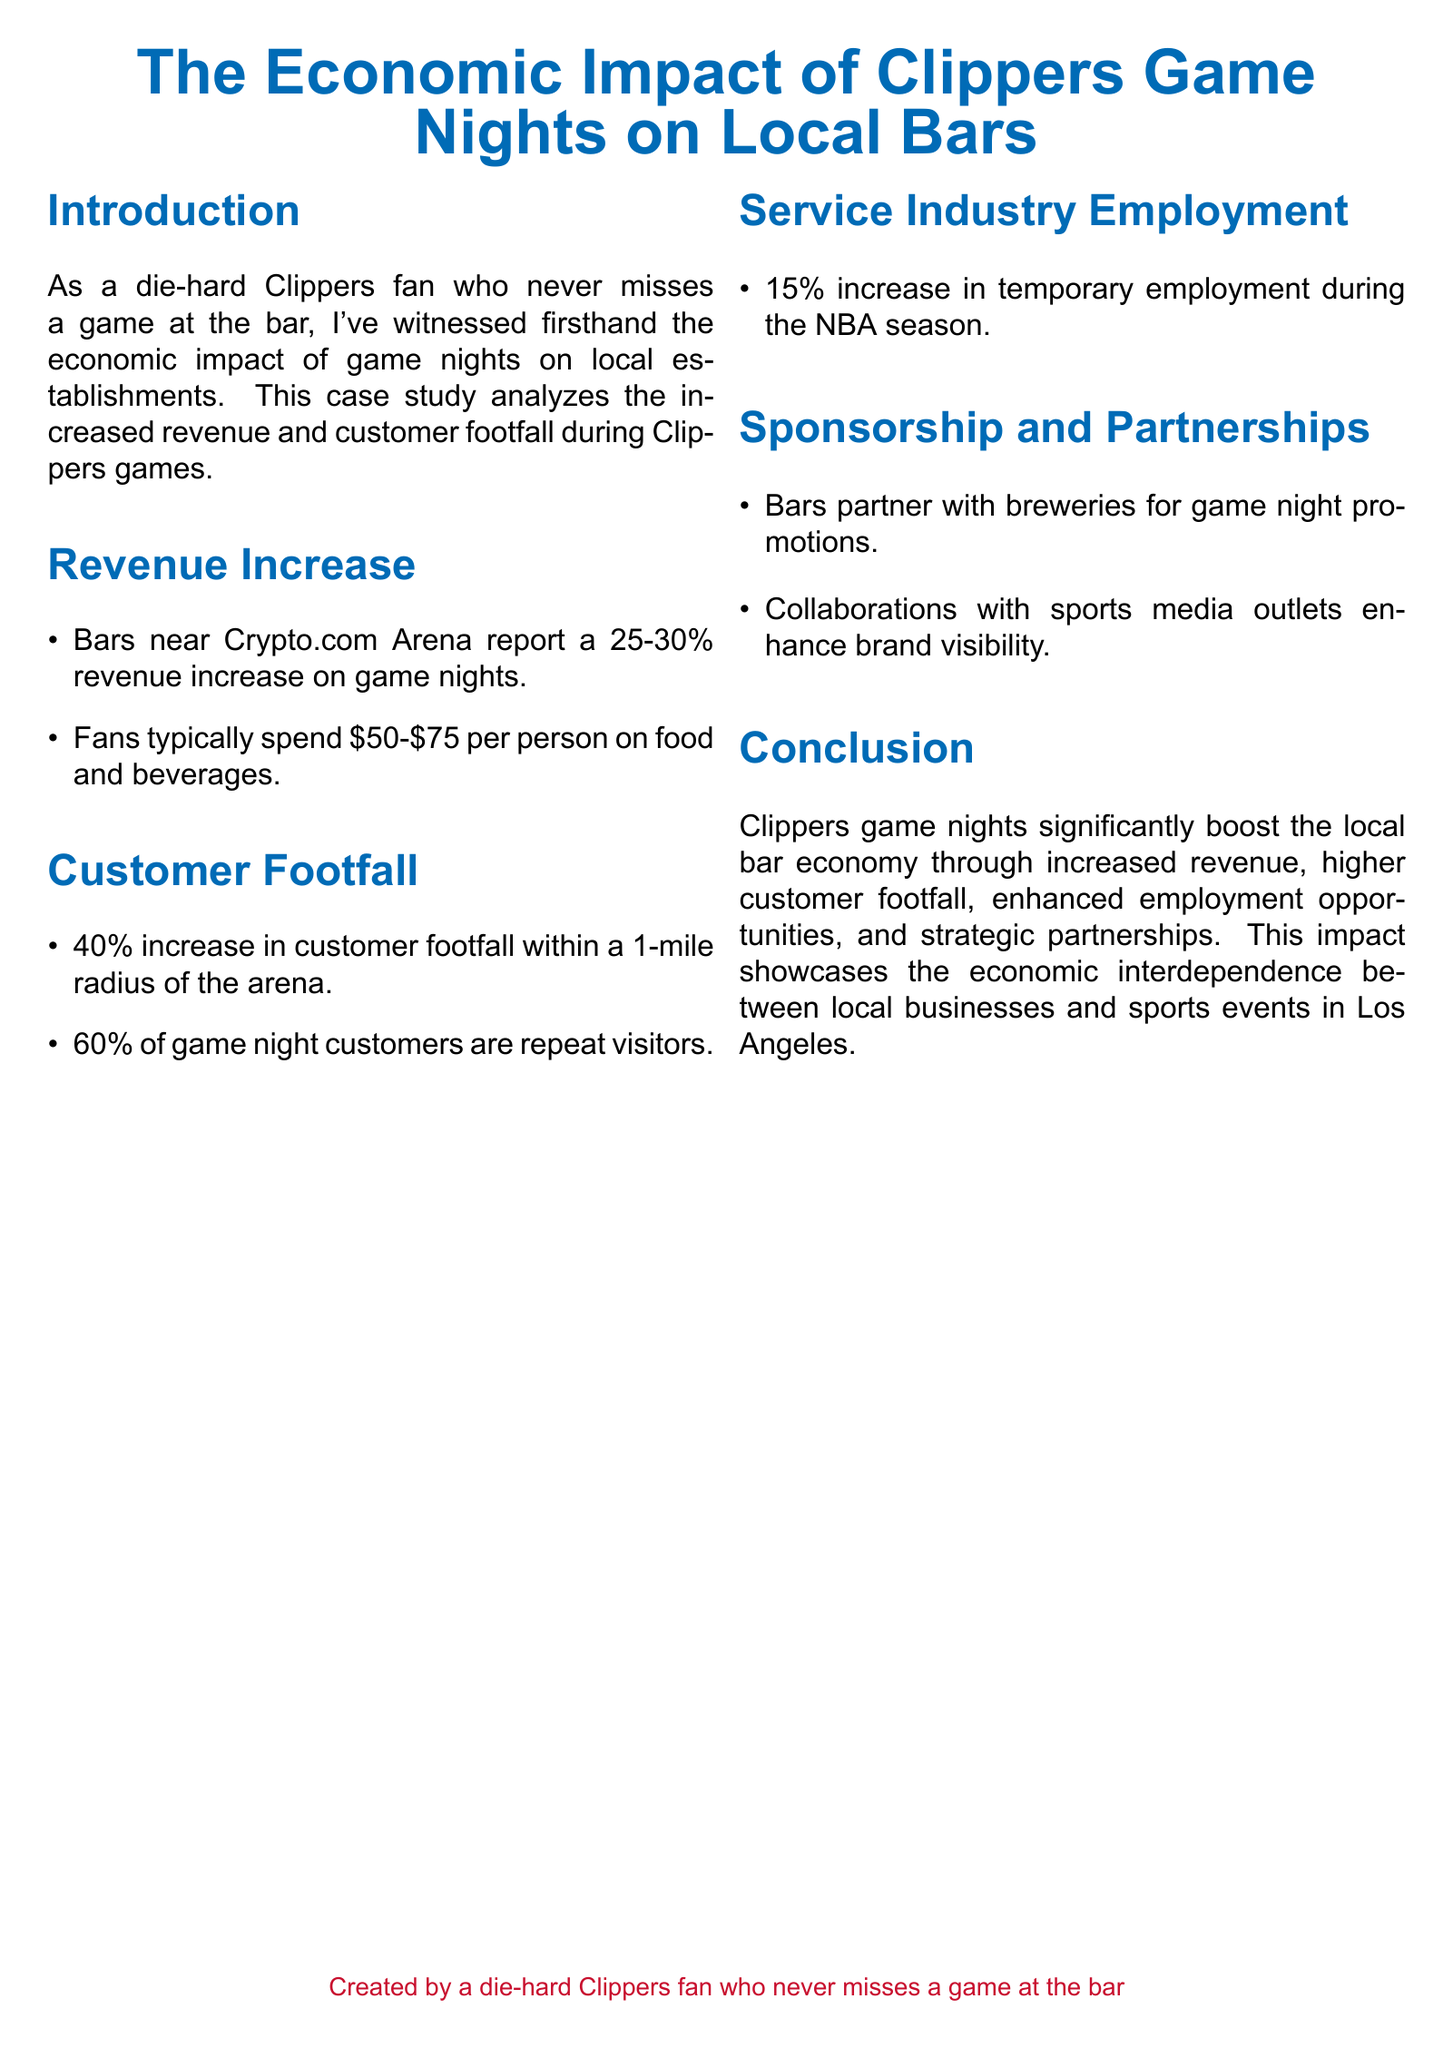What is the revenue increase reported by bars on game nights? Bars near Crypto.com Arena report a 25-30% revenue increase on game nights.
Answer: 25-30% What is the typical spending per person on food and beverages during a game night? Fans typically spend $50-$75 per person on food and beverages.
Answer: $50-$75 What percentage increase in customer footfall is reported within a 1-mile radius of the arena? There is a 40% increase in customer footfall within a 1-mile radius of the arena.
Answer: 40% What is the percentage of game night customers who are repeat visitors? 60% of game night customers are repeat visitors.
Answer: 60% What is the increase in temporary employment during the NBA season? There is a 15% increase in temporary employment during the NBA season.
Answer: 15% What do bars partner with breweries for? Bars partner with breweries for game night promotions.
Answer: Game night promotions What is the significance of collaborations with sports media outlets? Collaborations with sports media outlets enhance brand visibility.
Answer: Brand visibility What does this case study demonstrate about local businesses and sports events? This impact showcases the economic interdependence between local businesses and sports events in Los Angeles.
Answer: Economic interdependence 